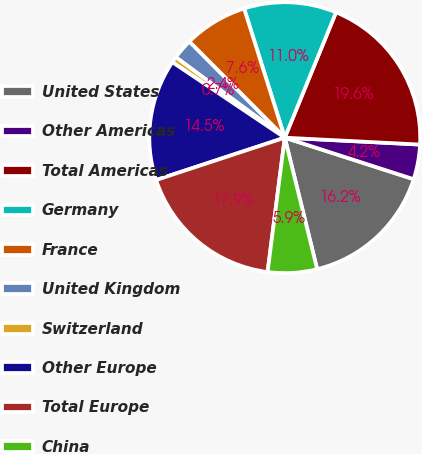Convert chart to OTSL. <chart><loc_0><loc_0><loc_500><loc_500><pie_chart><fcel>United States<fcel>Other Americas<fcel>Total Americas<fcel>Germany<fcel>France<fcel>United Kingdom<fcel>Switzerland<fcel>Other Europe<fcel>Total Europe<fcel>China<nl><fcel>16.19%<fcel>4.15%<fcel>19.63%<fcel>11.03%<fcel>7.59%<fcel>2.43%<fcel>0.71%<fcel>14.47%<fcel>17.91%<fcel>5.87%<nl></chart> 